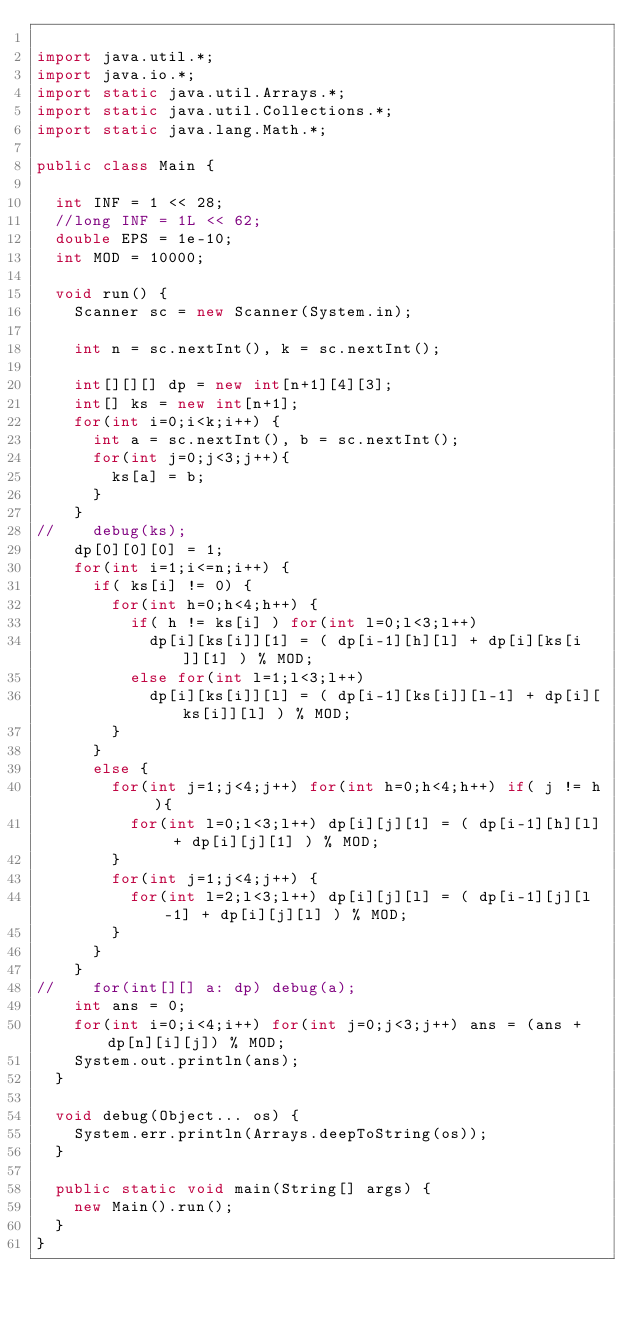<code> <loc_0><loc_0><loc_500><loc_500><_Java_>
import java.util.*;
import java.io.*;
import static java.util.Arrays.*;
import static java.util.Collections.*;
import static java.lang.Math.*;

public class Main {

	int INF = 1 << 28;
	//long INF = 1L << 62;
	double EPS = 1e-10;
	int MOD = 10000;
	
	void run() {
		Scanner sc = new Scanner(System.in);
		
		int n = sc.nextInt(), k = sc.nextInt();
		
		int[][][] dp = new int[n+1][4][3];
		int[] ks = new int[n+1];
		for(int i=0;i<k;i++) {
			int a = sc.nextInt(), b = sc.nextInt();
			for(int j=0;j<3;j++){
				ks[a] = b;
			}
		}
//		debug(ks);
		dp[0][0][0] = 1;
		for(int i=1;i<=n;i++) {
			if( ks[i] != 0) {
				for(int h=0;h<4;h++) {
					if( h != ks[i] ) for(int l=0;l<3;l++) 
						dp[i][ks[i]][1] = ( dp[i-1][h][l] + dp[i][ks[i]][1] ) % MOD;
					else for(int l=1;l<3;l++) 
						dp[i][ks[i]][l] = ( dp[i-1][ks[i]][l-1] + dp[i][ks[i]][l] ) % MOD;
				}
			}
			else {
				for(int j=1;j<4;j++) for(int h=0;h<4;h++) if( j != h ){
					for(int l=0;l<3;l++) dp[i][j][1] = ( dp[i-1][h][l] + dp[i][j][1] ) % MOD;
				}
				for(int j=1;j<4;j++) {
					for(int l=2;l<3;l++) dp[i][j][l] = ( dp[i-1][j][l-1] + dp[i][j][l] ) % MOD;
				}
			}
		}
//		for(int[][] a: dp) debug(a);
		int ans = 0;
		for(int i=0;i<4;i++) for(int j=0;j<3;j++) ans = (ans + dp[n][i][j]) % MOD;
		System.out.println(ans);
	}

	void debug(Object... os) {
		System.err.println(Arrays.deepToString(os));
	}

	public static void main(String[] args) {
		new Main().run();
	}
}</code> 